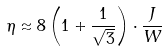<formula> <loc_0><loc_0><loc_500><loc_500>\eta \approx 8 \left ( 1 + \frac { 1 } { \sqrt { 3 } } \right ) \cdot \frac { J } { W }</formula> 